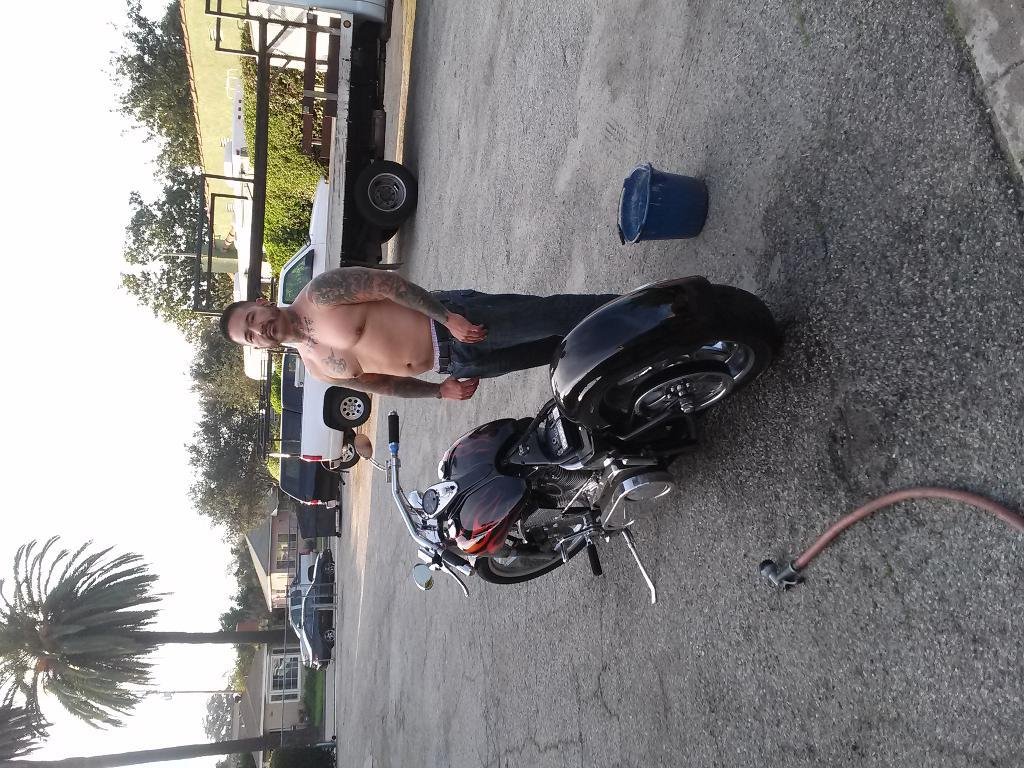Who is present in the image? There is a man in the image. What object can be seen near the man? There is a bucket in the image. What other object is visible in the image? There is a pipe in the image. What is on the road in the image? There is a bike on the road in the image. What can be seen in the distance in the image? Vehicles, houses with windows, trees, and the sky are visible in the background of the image. What type of jeans is the man wearing in the image? There is no mention of jeans in the image, so it cannot be determined what type the man might be wearing. 